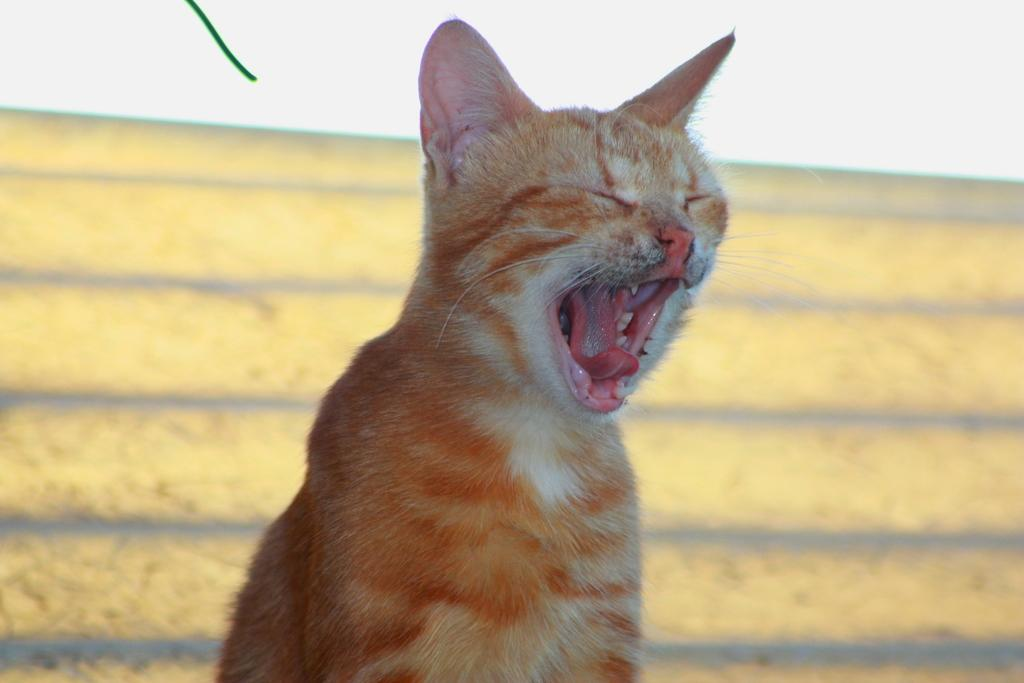What animal is present in the image? There is a cat in the image. What is the cat doing in the image? The cat is opening its mouth. Can you describe the background color in the image? The background color appears to be light yellow and white. What type of cushion is the cat sitting on in the image? There is no cushion present in the image; the cat is not sitting on anything. 